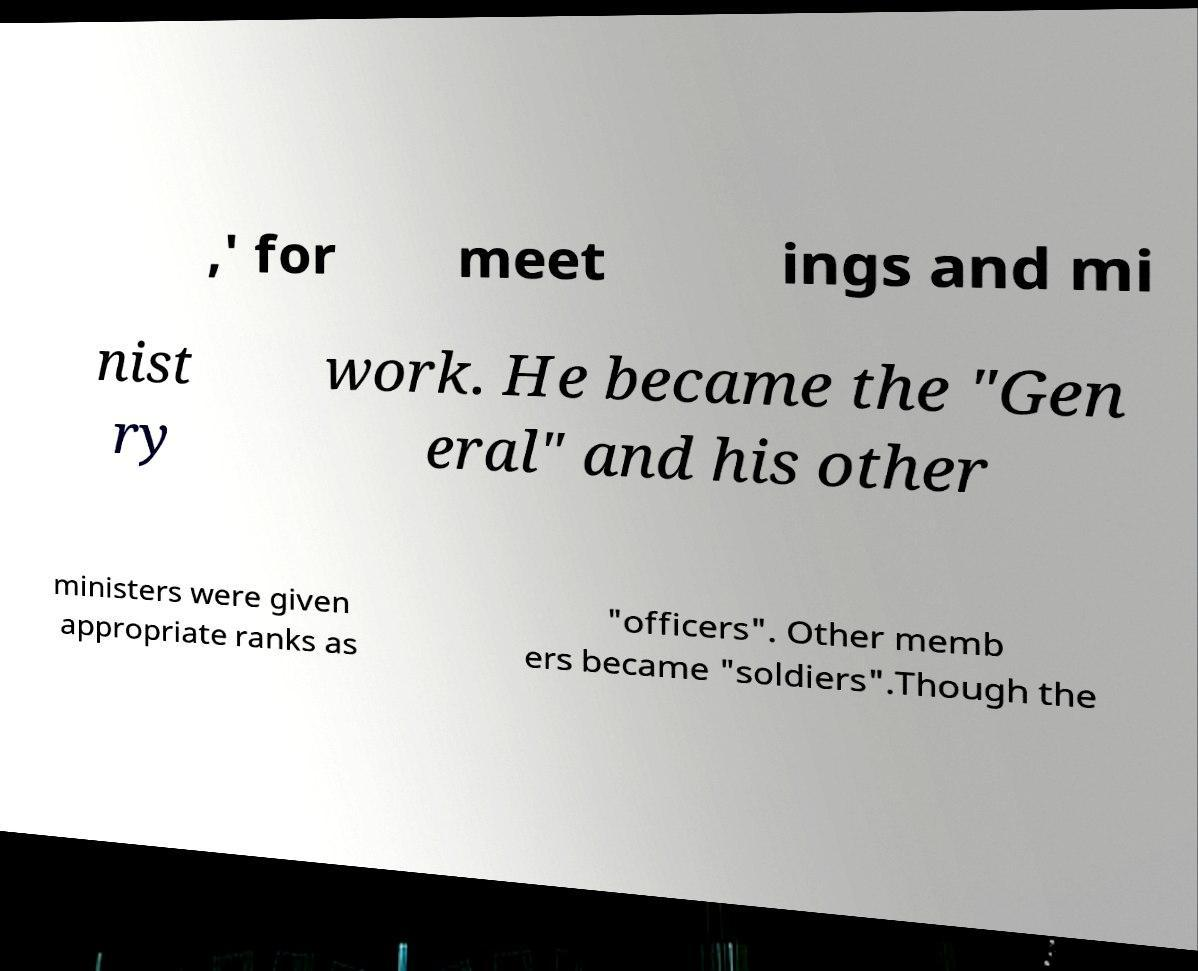For documentation purposes, I need the text within this image transcribed. Could you provide that? ,' for meet ings and mi nist ry work. He became the "Gen eral" and his other ministers were given appropriate ranks as "officers". Other memb ers became "soldiers".Though the 